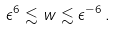<formula> <loc_0><loc_0><loc_500><loc_500>\epsilon ^ { 6 } \lesssim w \lesssim \epsilon ^ { - 6 } \, .</formula> 